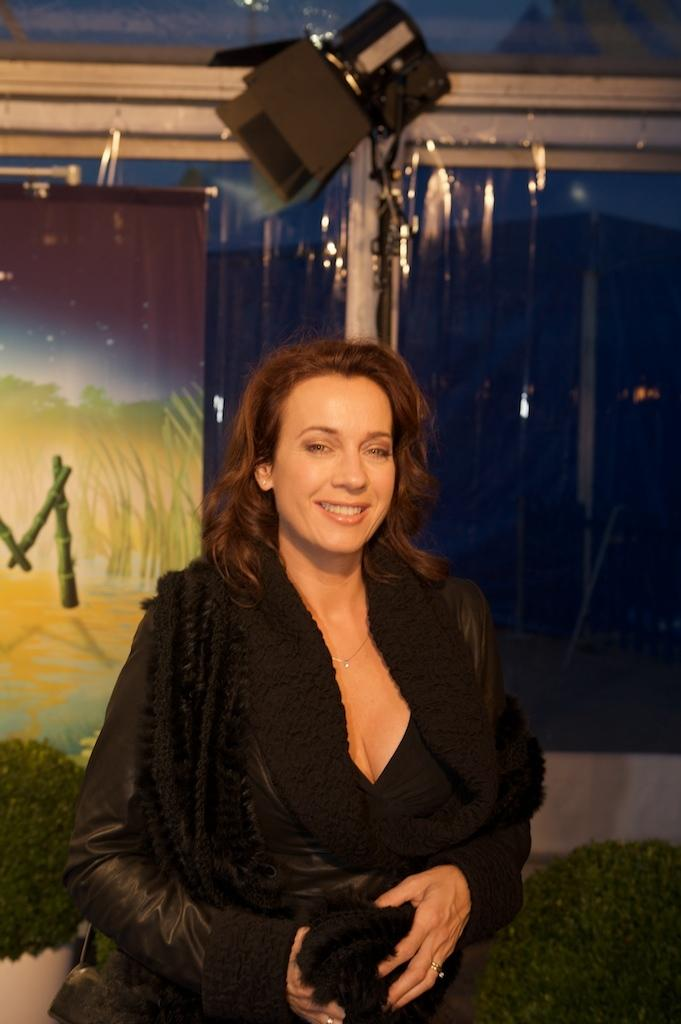What is the main subject of the image? The main subject of the image is a woman. What is the woman doing in the image? The woman is standing in the image. What is the woman wearing in the image? The woman is wearing clothes and a finger ring in the image. What is the woman's facial expression in the image? The woman is smiling in the image. What can be seen behind the woman in the image? There is a poster visible behind the woman in the image. What is visible in the background of the image? There is a window and grass visible in the background of the image. What type of attack is the woman planning in the image? There is no indication of an attack or any aggressive behavior in the image. The woman is simply standing and smiling. 